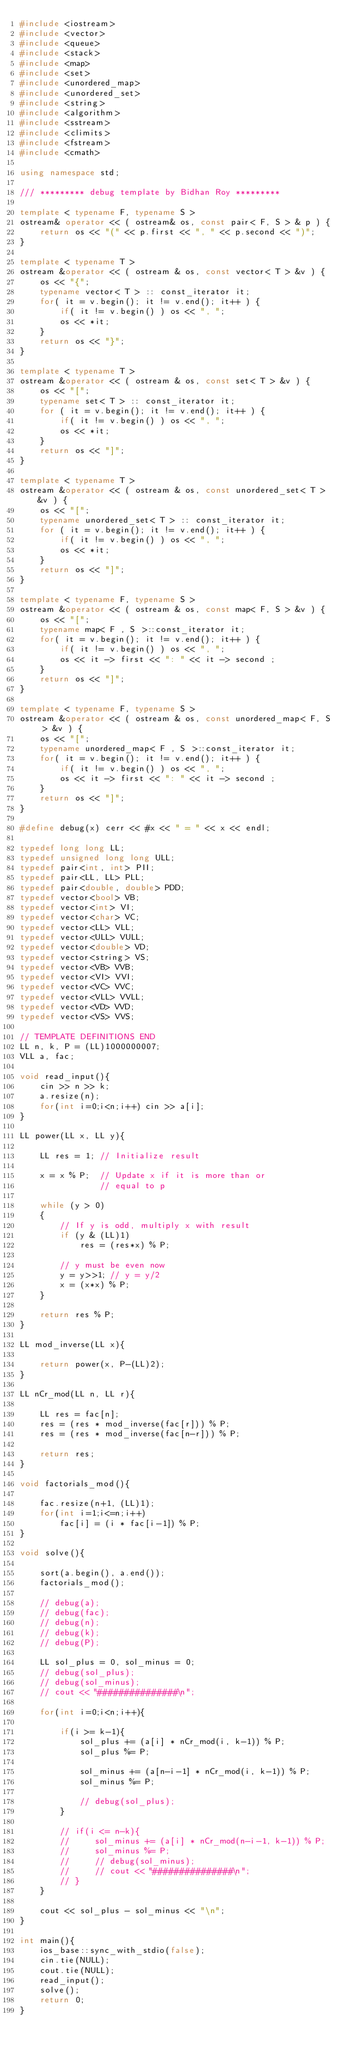Convert code to text. <code><loc_0><loc_0><loc_500><loc_500><_C++_>#include <iostream>
#include <vector>
#include <queue>
#include <stack>
#include <map>
#include <set>
#include <unordered_map>
#include <unordered_set>
#include <string>
#include <algorithm>
#include <sstream>
#include <climits>
#include <fstream>
#include <cmath>

using namespace std;

/// ********* debug template by Bidhan Roy *********

template < typename F, typename S >
ostream& operator << ( ostream& os, const pair< F, S > & p ) {
    return os << "(" << p.first << ", " << p.second << ")";
}

template < typename T >
ostream &operator << ( ostream & os, const vector< T > &v ) {
    os << "{";
    typename vector< T > :: const_iterator it;
    for( it = v.begin(); it != v.end(); it++ ) {
        if( it != v.begin() ) os << ", ";
        os << *it;
    }
    return os << "}";
}

template < typename T >
ostream &operator << ( ostream & os, const set< T > &v ) {
    os << "[";
    typename set< T > :: const_iterator it;
    for ( it = v.begin(); it != v.end(); it++ ) {
        if( it != v.begin() ) os << ", ";
        os << *it;
    }
    return os << "]";
}

template < typename T >
ostream &operator << ( ostream & os, const unordered_set< T > &v ) {
    os << "[";
    typename unordered_set< T > :: const_iterator it;
    for ( it = v.begin(); it != v.end(); it++ ) {
        if( it != v.begin() ) os << ", ";
        os << *it;
    }
    return os << "]";
}

template < typename F, typename S >
ostream &operator << ( ostream & os, const map< F, S > &v ) {
    os << "[";
    typename map< F , S >::const_iterator it;
    for( it = v.begin(); it != v.end(); it++ ) {
        if( it != v.begin() ) os << ", ";
        os << it -> first << ": " << it -> second ;
    }
    return os << "]";
}

template < typename F, typename S >
ostream &operator << ( ostream & os, const unordered_map< F, S > &v ) {
    os << "[";
    typename unordered_map< F , S >::const_iterator it;
    for( it = v.begin(); it != v.end(); it++ ) {
        if( it != v.begin() ) os << ", ";
        os << it -> first << ": " << it -> second ;
    } 
    return os << "]";
}

#define debug(x) cerr << #x << " = " << x << endl;

typedef long long LL;
typedef unsigned long long ULL;
typedef pair<int, int> PII;
typedef pair<LL, LL> PLL;
typedef pair<double, double> PDD;
typedef vector<bool> VB;
typedef vector<int> VI;
typedef vector<char> VC;
typedef vector<LL> VLL;
typedef vector<ULL> VULL;
typedef vector<double> VD;
typedef vector<string> VS;
typedef vector<VB> VVB;
typedef vector<VI> VVI;
typedef vector<VC> VVC;
typedef vector<VLL> VVLL;
typedef vector<VD> VVD;
typedef vector<VS> VVS;

// TEMPLATE DEFINITIONS END
LL n, k, P = (LL)1000000007;
VLL a, fac;

void read_input(){
    cin >> n >> k;
    a.resize(n);
    for(int i=0;i<n;i++) cin >> a[i];
}

LL power(LL x, LL y){ 
    
    LL res = 1; // Initialize result 
  
    x = x % P;  // Update x if it is more than or 
                // equal to p 
  
    while (y > 0) 
    { 
        // If y is odd, multiply x with result 
        if (y & (LL)1) 
            res = (res*x) % P; 
  
        // y must be even now 
        y = y>>1; // y = y/2 
        x = (x*x) % P; 
    }

    return res % P; 
} 

LL mod_inverse(LL x){

    return power(x, P-(LL)2);
}

LL nCr_mod(LL n, LL r){

    LL res = fac[n];
    res = (res * mod_inverse(fac[r])) % P;
    res = (res * mod_inverse(fac[n-r])) % P;
    
    return res;
}

void factorials_mod(){

    fac.resize(n+1, (LL)1);
    for(int i=1;i<=n;i++)
        fac[i] = (i * fac[i-1]) % P;
}

void solve(){

    sort(a.begin(), a.end());
    factorials_mod();
    
    // debug(a);
    // debug(fac);
    // debug(n);
    // debug(k);
    // debug(P);
    
    LL sol_plus = 0, sol_minus = 0;
    // debug(sol_plus);
    // debug(sol_minus);
    // cout << "###############\n";

    for(int i=0;i<n;i++){

        if(i >= k-1){
            sol_plus += (a[i] * nCr_mod(i, k-1)) % P;
            sol_plus %= P;

            sol_minus += (a[n-i-1] * nCr_mod(i, k-1)) % P;
            sol_minus %= P;

            // debug(sol_plus);
        }

        // if(i <= n-k){
        //     sol_minus += (a[i] * nCr_mod(n-i-1, k-1)) % P;
        //     sol_minus %= P;
        //     // debug(sol_minus);
        //     // cout << "###############\n";
        // }
    }

    cout << sol_plus - sol_minus << "\n";
}

int main(){
    ios_base::sync_with_stdio(false);
    cin.tie(NULL);
    cout.tie(NULL);
    read_input();
    solve();
    return 0;
}
</code> 